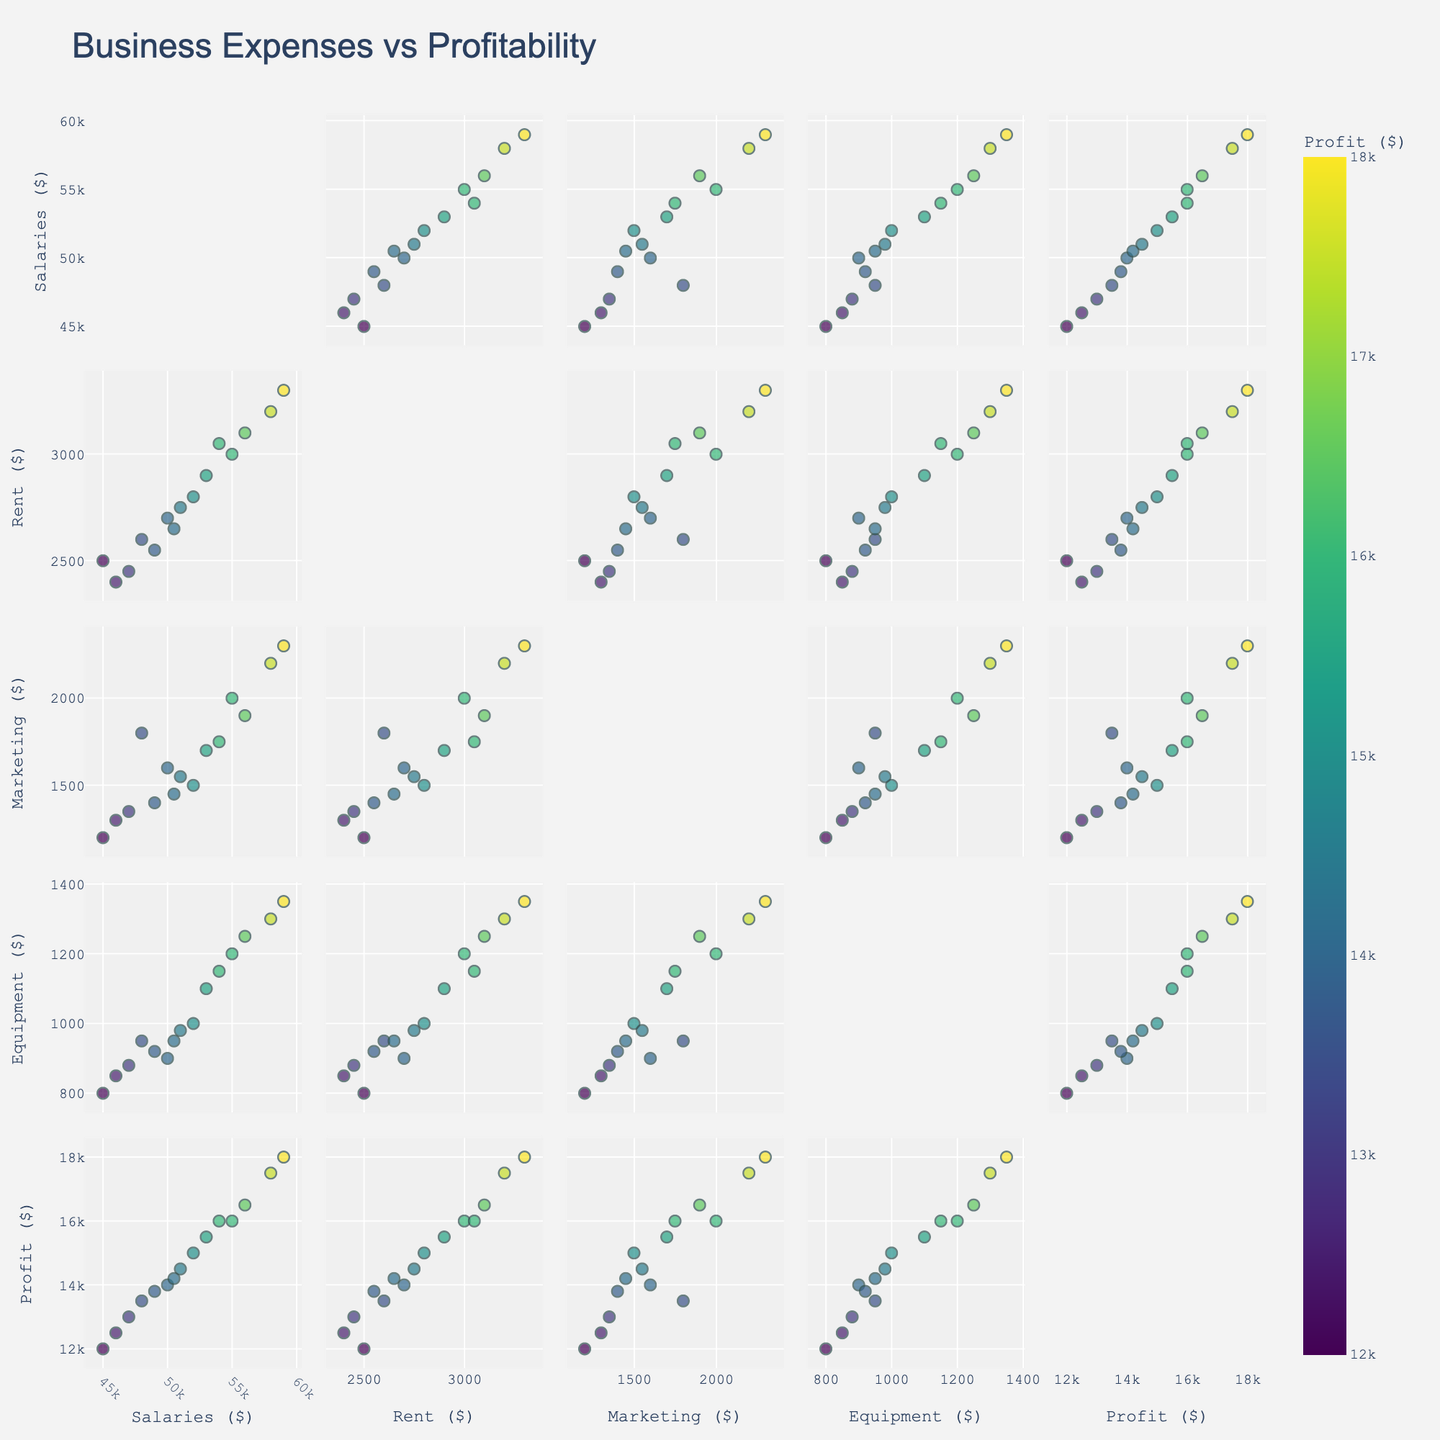What's the title of the figure? The title is usually displayed at the top of the figure, and it provides an overview of what the scatterplot matrix is about.
Answer: Business Expenses vs Profitability What does the color of the points represent? In scatterplot matrices, colors often represent the variable being visualized across all pairs of dimensions. This helps in understanding patterns related to the color-coded variable.
Answer: Profitability How many data points are there in the plot? You can count the number of dots visible in one of the off-diagonal scatterplots. Since each point represents an entry in the dataset, counting them in one pair will give the total number.
Answer: 15 Which expense has the highest correlation with profitability? To determine which expense is most correlated with profitability, observe the scatterplots where Profitability is one of the axes and see which has points that form the most linear pattern.
Answer: Employee_Salaries Is there a noticeable trend between Marketing Expenses and Profitability? Look at the scatterplot with Marketing Expenses on one axis and Profitability on the other, and identify if the points form any clear pattern or trend, such as a line.
Answer: Yes Does increasing Office Rent correlate with higher or lower profitability? By examining the scatterplot that plots Office Rent against Profitability, you can see if higher rent corresponds with higher or lower profitability based on the direction of the trend.
Answer: Higher What is the range of Employee Salaries in this data? Find the lowest and highest values on the Employee Salaries axis across the scatterplot matrix.
Answer: 45000–59000 If you were to choose one expense to decrease without lowering profitability, which would it be? By examining the scatterplots, identify any expense that shows little to no correlation with profitability.
Answer: Equipment_Costs Which pair of expenses shows the least correlation? Look for the scatterplots with the least visible pattern among the Expense pairs (excluding Profitability) in the matrix.
Answer: Equipment_Costs and Office_Rent What's the average profitability for companies paying around $3000 in Office Rent? Look at the scatterplot between Office Rent and Profitability, find points around the $3000 rent mark, and calculate the average profitability for these points.
Answer: 16000 